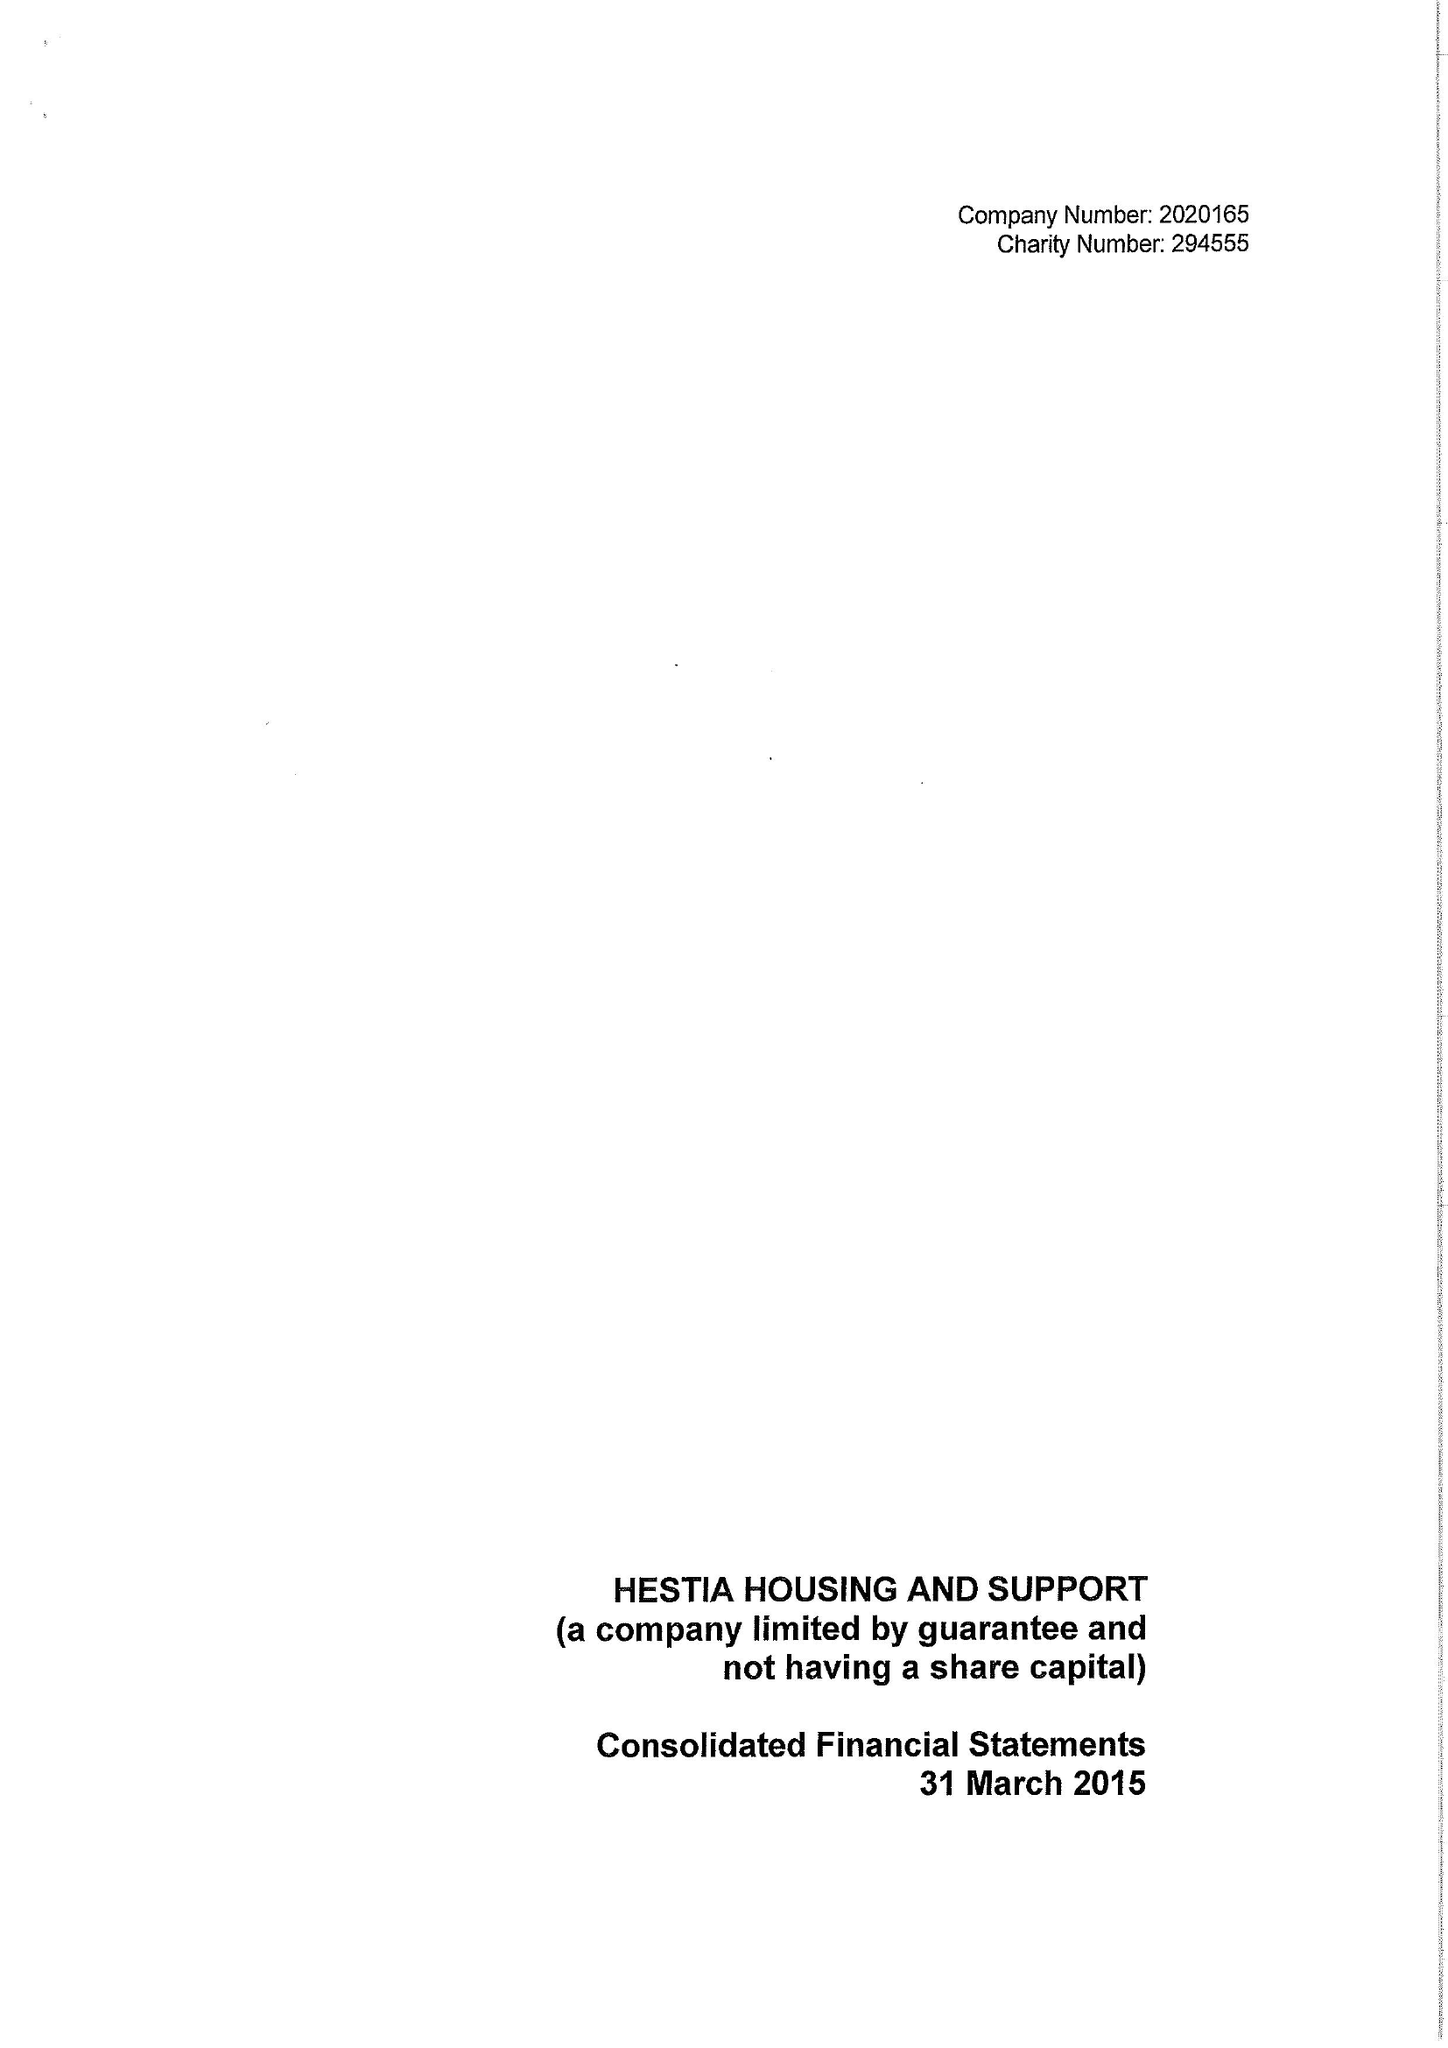What is the value for the address__street_line?
Answer the question using a single word or phrase. 134-138 BOROUGH HIGH STREET 